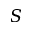<formula> <loc_0><loc_0><loc_500><loc_500>S</formula> 